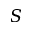<formula> <loc_0><loc_0><loc_500><loc_500>S</formula> 